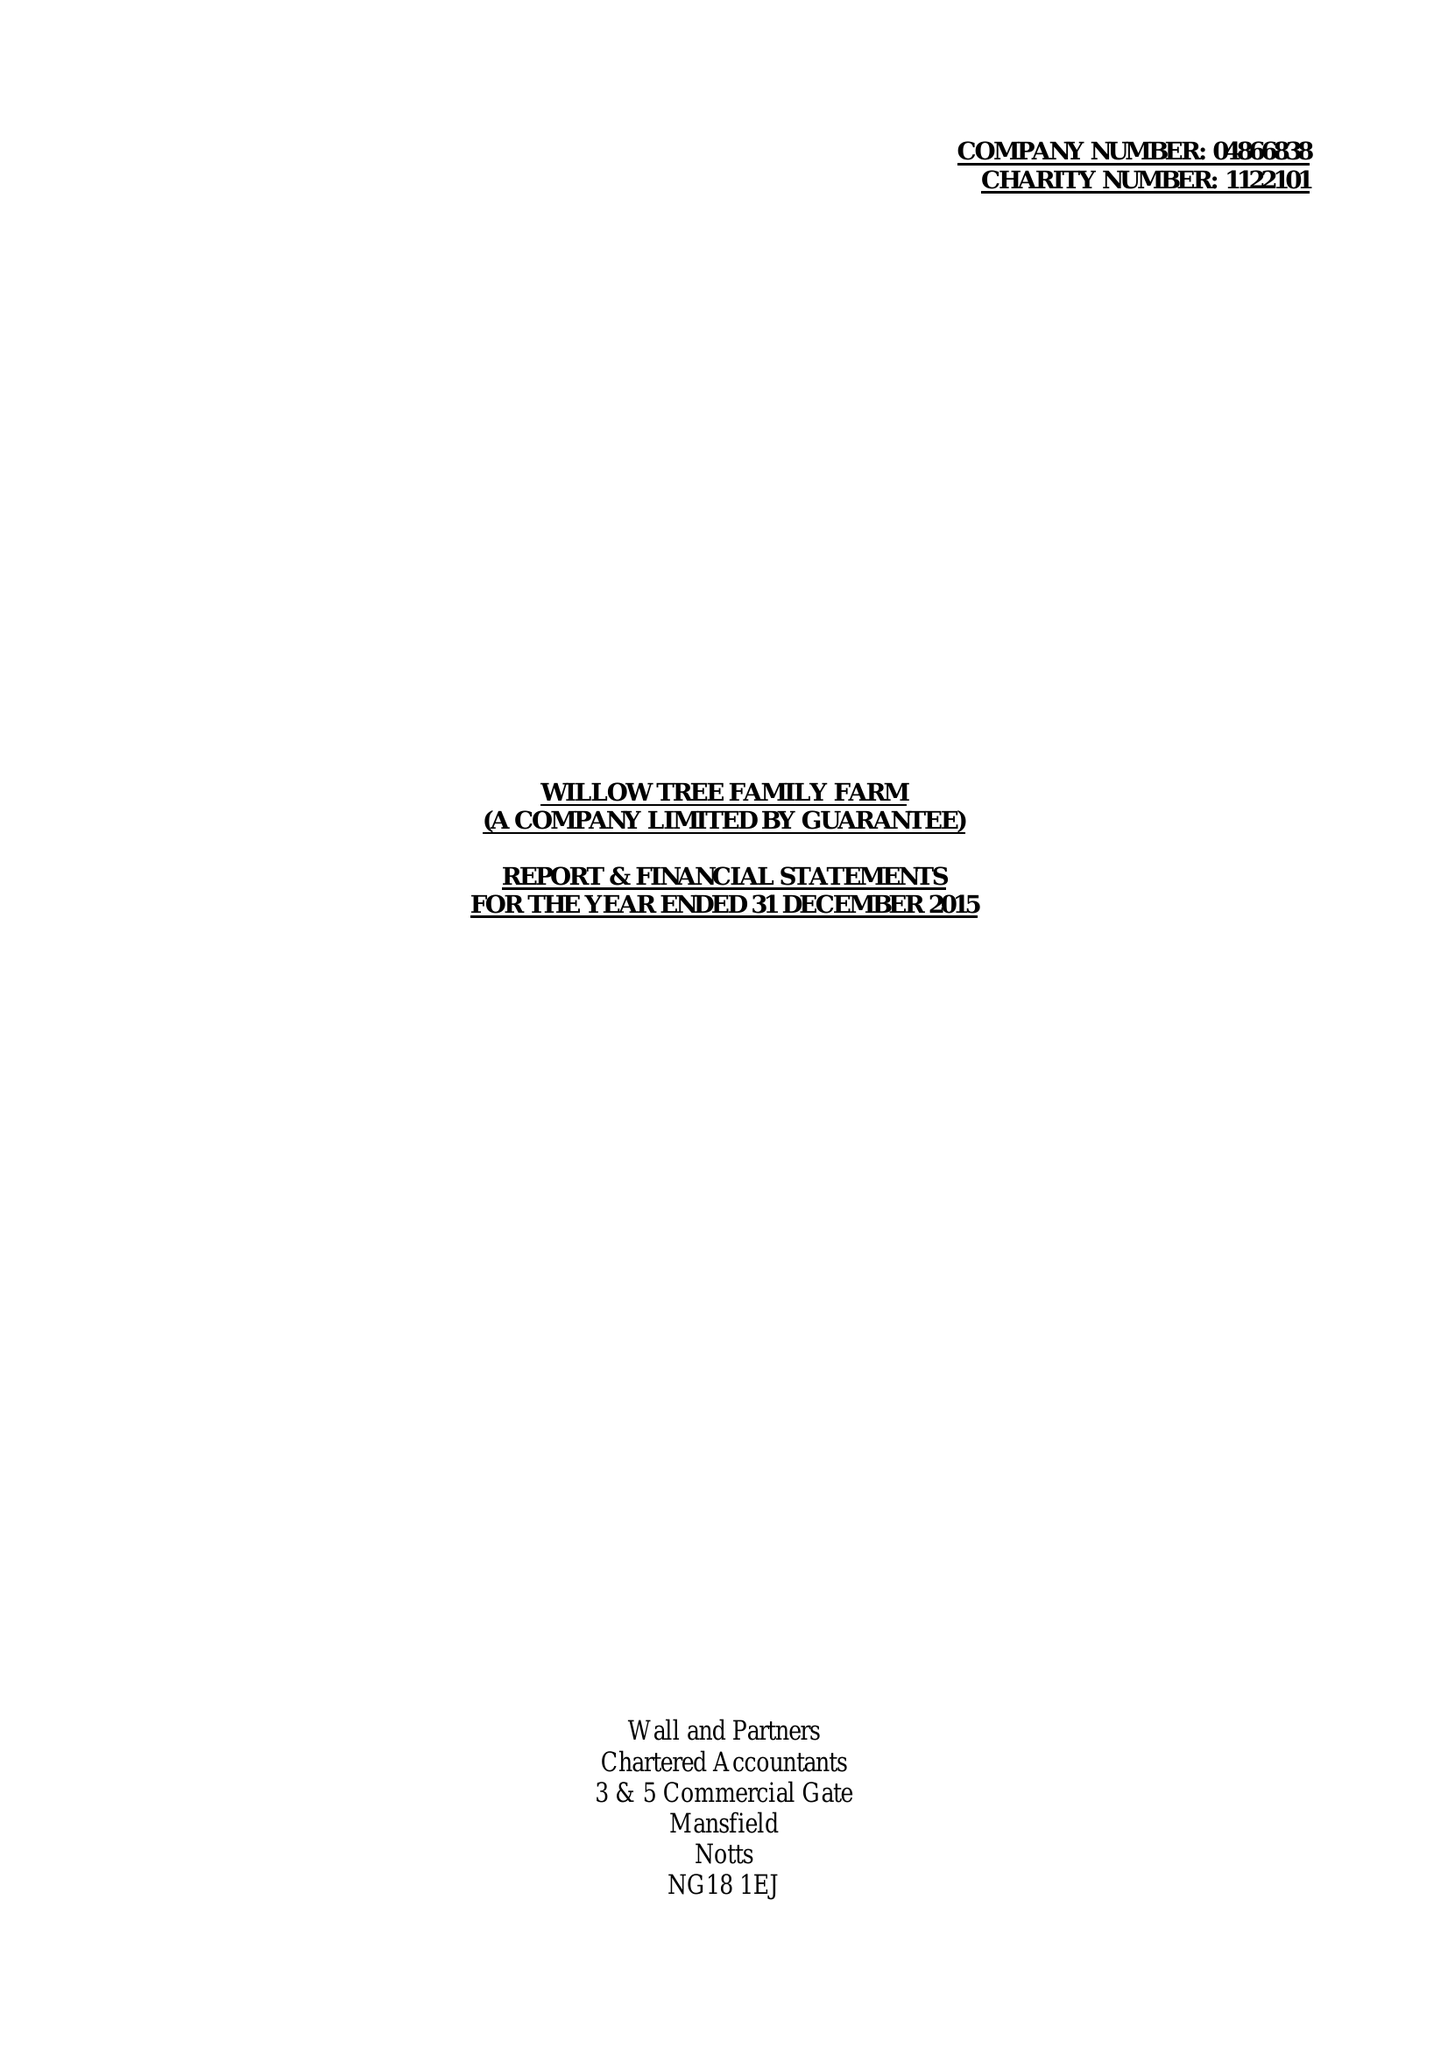What is the value for the report_date?
Answer the question using a single word or phrase. 2015-12-31 